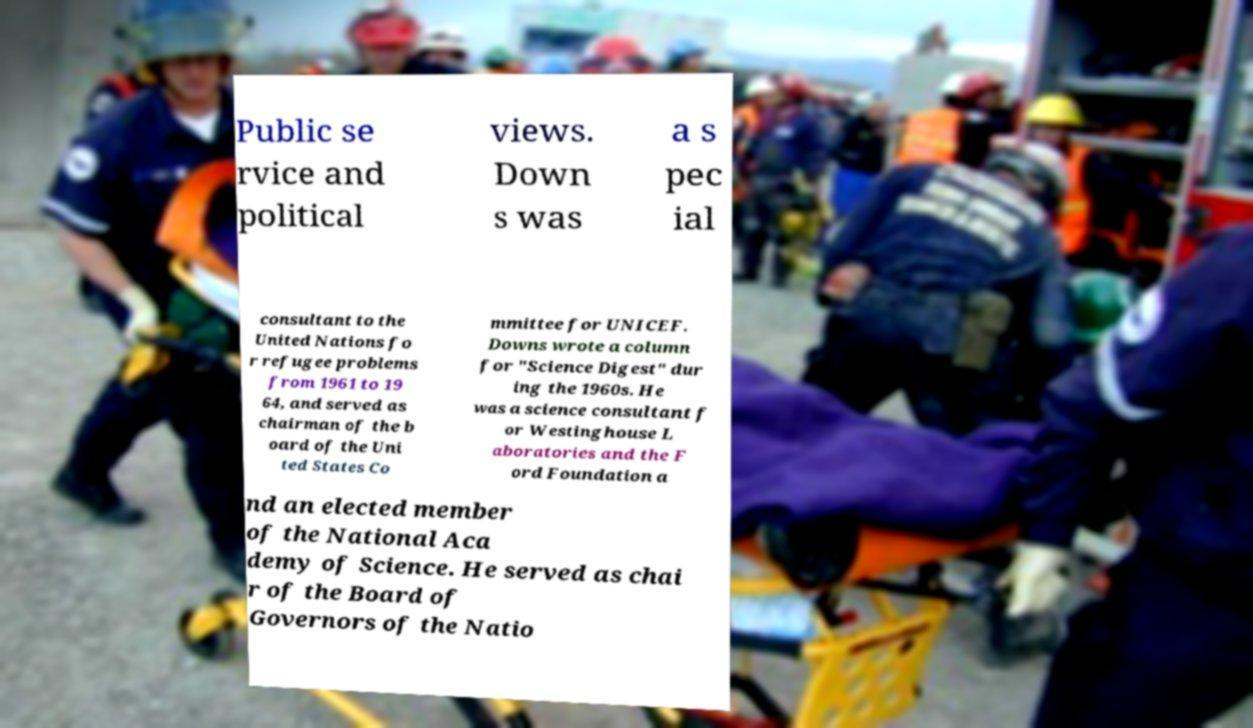For documentation purposes, I need the text within this image transcribed. Could you provide that? Public se rvice and political views. Down s was a s pec ial consultant to the United Nations fo r refugee problems from 1961 to 19 64, and served as chairman of the b oard of the Uni ted States Co mmittee for UNICEF. Downs wrote a column for "Science Digest" dur ing the 1960s. He was a science consultant f or Westinghouse L aboratories and the F ord Foundation a nd an elected member of the National Aca demy of Science. He served as chai r of the Board of Governors of the Natio 